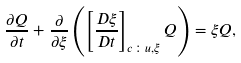<formula> <loc_0><loc_0><loc_500><loc_500>\frac { \partial Q } { \partial t } + \frac { \partial } { \partial \xi } \left ( \left [ \frac { D \xi } { D t } \right ] _ { c \colon u , \xi } Q \right ) = { \xi } Q ,</formula> 